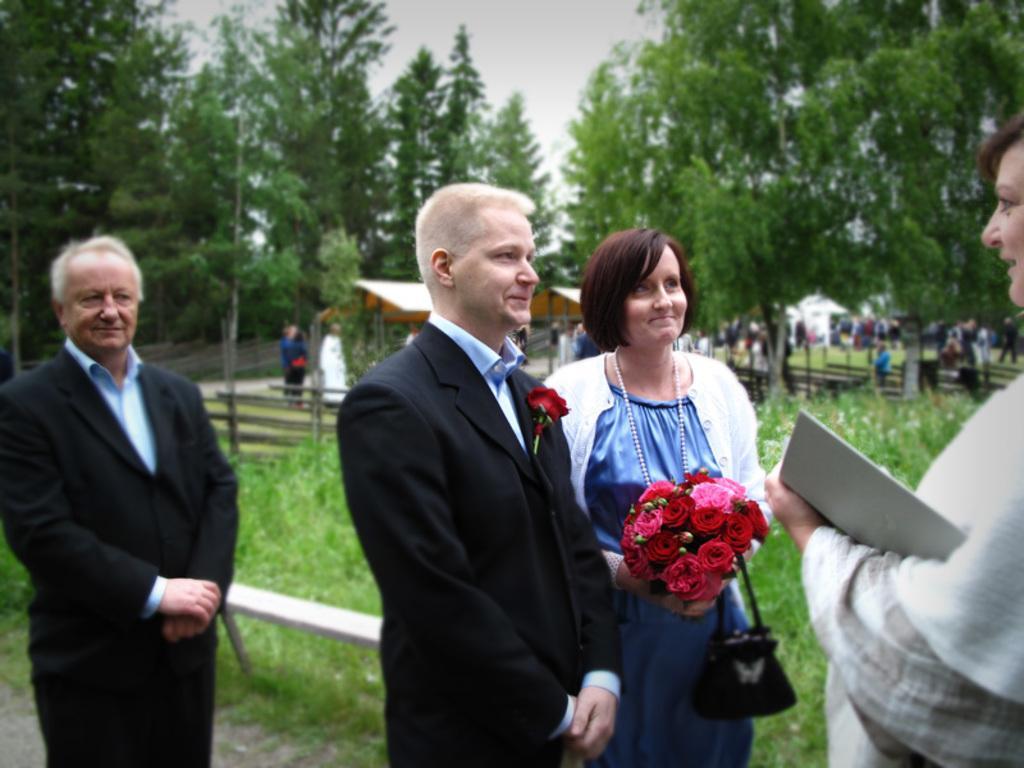How would you summarize this image in a sentence or two? in the given picture i can see the group of people and also i can see trees and garden and i can a person holding a book and watching two people and i can see a person wearing a white jacket and holding bunch of flowers and holding a bag and next to that person who is wearing suit and looking at a person and they is a rose which is attached to the suit and also i can see other person , who is standing and watch this three people. 